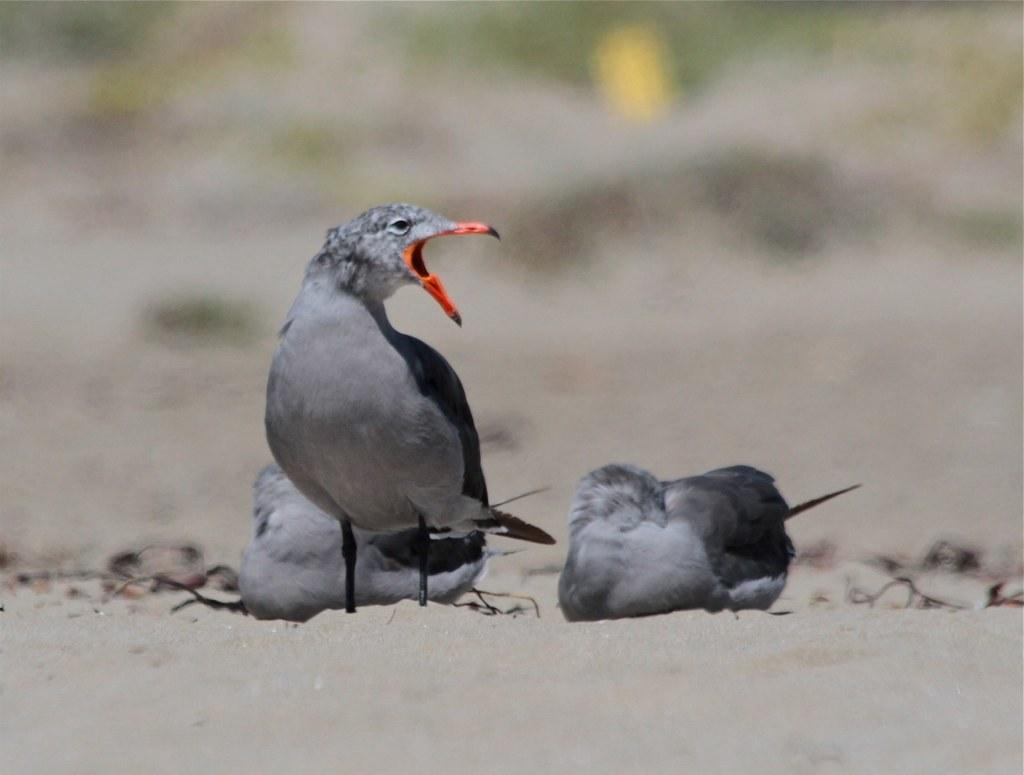What type of birds can be seen in the image? There are grey color birds in the image. Where are the birds located? The birds are on the ground. Can you describe the background of the image? The image is blurry in the background. What type of club can be seen in the image? There is no club present in the image; it features grey color birds on the ground. Is the snow visible in the image? There is no snow present in the image; it features grey color birds on the ground. 